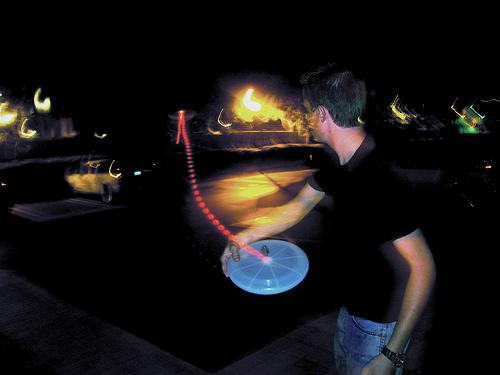Question: when was the picture taken?
Choices:
A. During the day.
B. At night.
C. At dusk.
D. At dawn.
Answer with the letter. Answer: B Question: what is on the man's wrist?
Choices:
A. A bracelet.
B. A rubberband.
C. A watch.
D. A hairtie.
Answer with the letter. Answer: C Question: what is in the man's hand?
Choices:
A. A basketball.
B. A frisbee.
C. A baseball.
D. A football.
Answer with the letter. Answer: B 